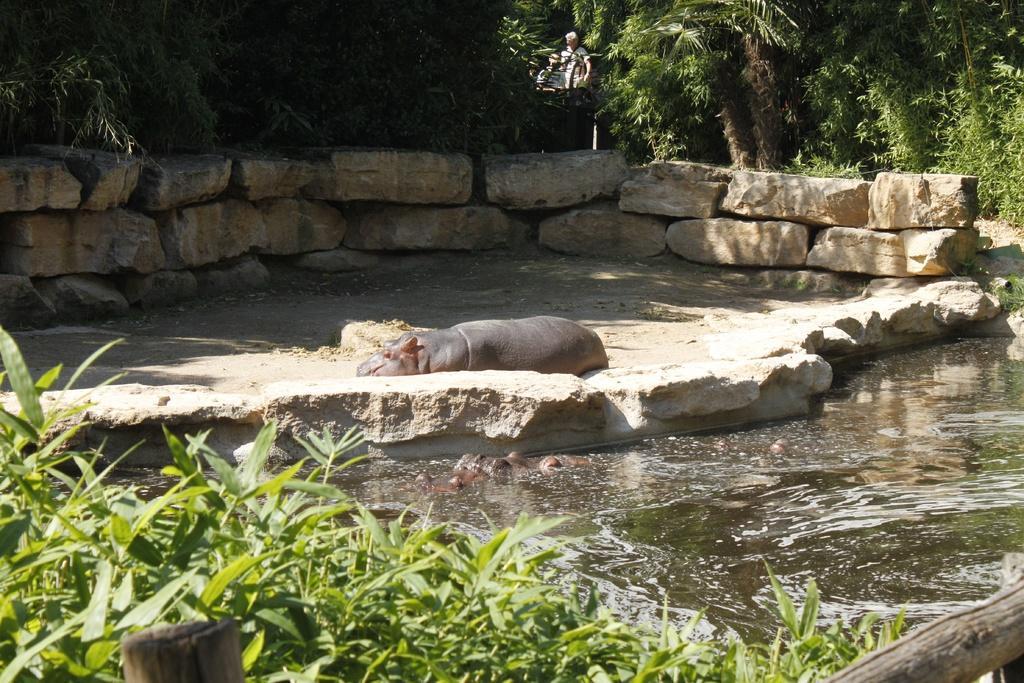Could you give a brief overview of what you see in this image? This is animal, this is water, these are trees. 